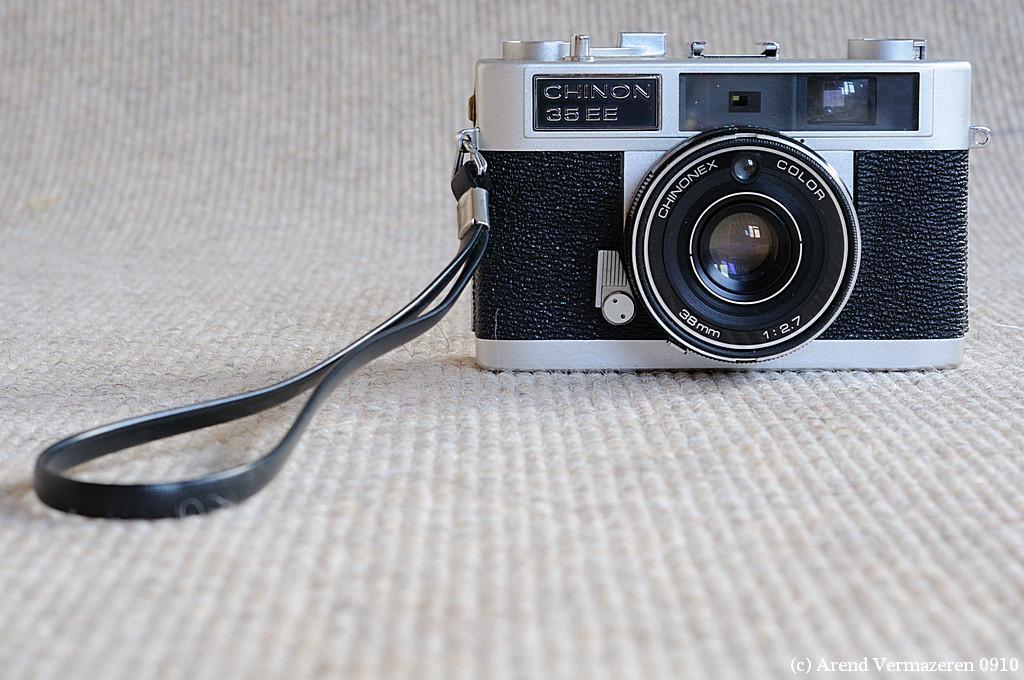Describe this image in one or two sentences. On the bottom right, there is a watermark. On the right side, there is a gray color camera arranged on a surface. And the background is gray in color. 